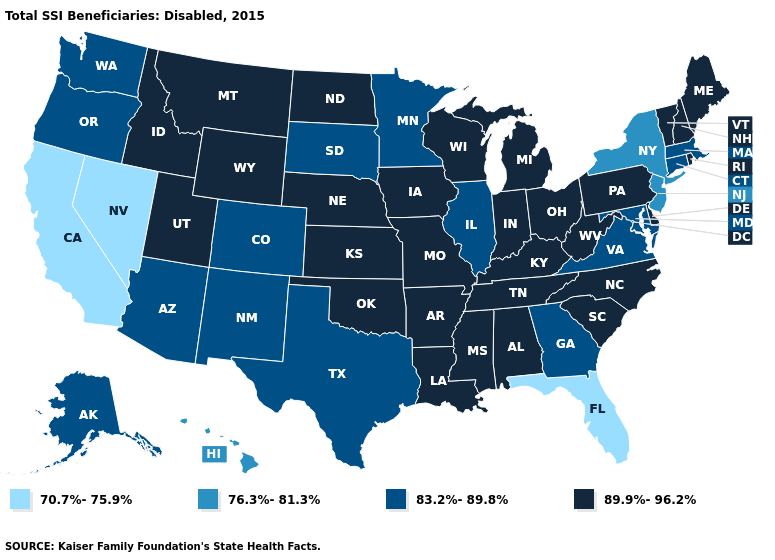Name the states that have a value in the range 83.2%-89.8%?
Write a very short answer. Alaska, Arizona, Colorado, Connecticut, Georgia, Illinois, Maryland, Massachusetts, Minnesota, New Mexico, Oregon, South Dakota, Texas, Virginia, Washington. Does New Hampshire have the lowest value in the Northeast?
Write a very short answer. No. Which states hav the highest value in the South?
Concise answer only. Alabama, Arkansas, Delaware, Kentucky, Louisiana, Mississippi, North Carolina, Oklahoma, South Carolina, Tennessee, West Virginia. Name the states that have a value in the range 83.2%-89.8%?
Write a very short answer. Alaska, Arizona, Colorado, Connecticut, Georgia, Illinois, Maryland, Massachusetts, Minnesota, New Mexico, Oregon, South Dakota, Texas, Virginia, Washington. Which states have the lowest value in the USA?
Quick response, please. California, Florida, Nevada. Among the states that border New York , which have the highest value?
Answer briefly. Pennsylvania, Vermont. What is the value of Idaho?
Be succinct. 89.9%-96.2%. Does Georgia have a higher value than Rhode Island?
Be succinct. No. What is the value of Rhode Island?
Be succinct. 89.9%-96.2%. Which states have the lowest value in the MidWest?
Concise answer only. Illinois, Minnesota, South Dakota. Does the first symbol in the legend represent the smallest category?
Quick response, please. Yes. Does the map have missing data?
Keep it brief. No. What is the value of Oregon?
Short answer required. 83.2%-89.8%. Among the states that border Ohio , which have the lowest value?
Keep it brief. Indiana, Kentucky, Michigan, Pennsylvania, West Virginia. Among the states that border North Carolina , does Georgia have the highest value?
Keep it brief. No. 